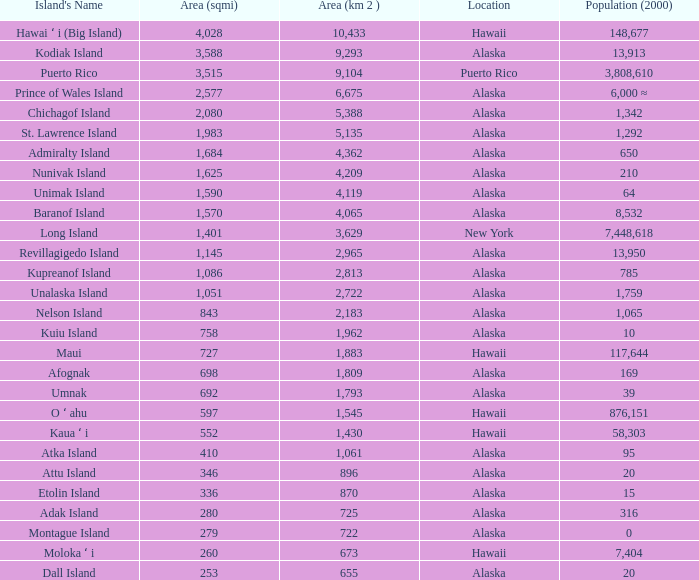What is the largest rank with 2,080 area? 5.0. 